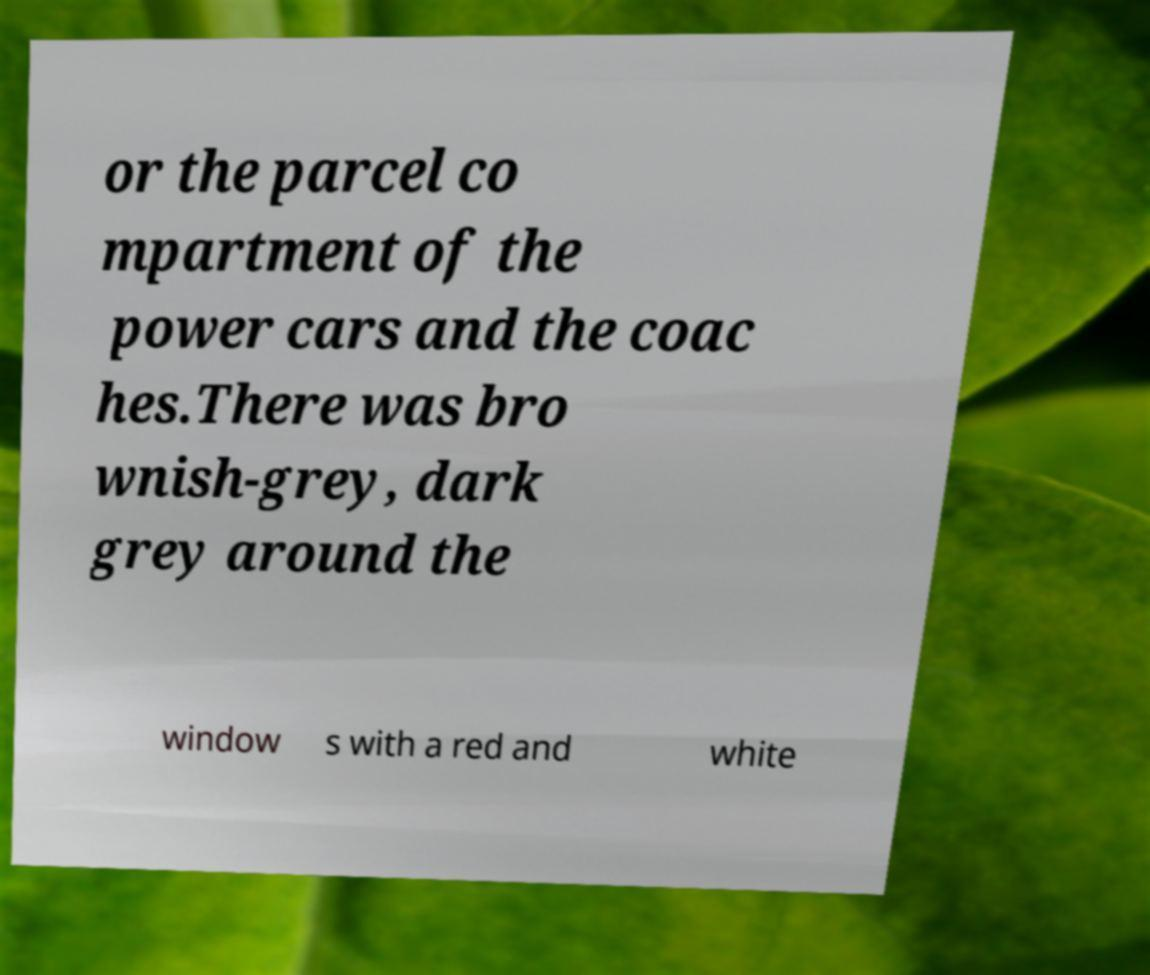I need the written content from this picture converted into text. Can you do that? or the parcel co mpartment of the power cars and the coac hes.There was bro wnish-grey, dark grey around the window s with a red and white 